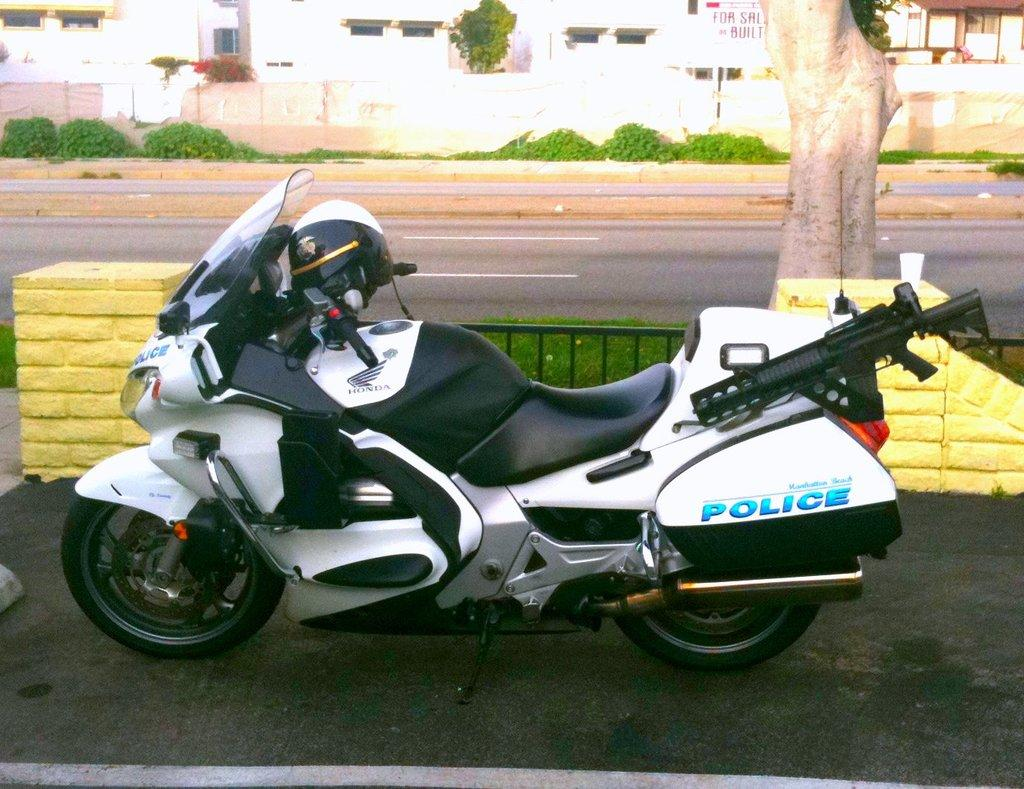What is the main subject of the image? The main subject of the image is a bike. Where is the bike located? The bike is on a road. What is behind the bike? There is a railing, a tree, another road, plants, and a building behind the bike. What type of education is being offered to the dogs in the image? There are no dogs present in the image, and therefore no education is being offered. 